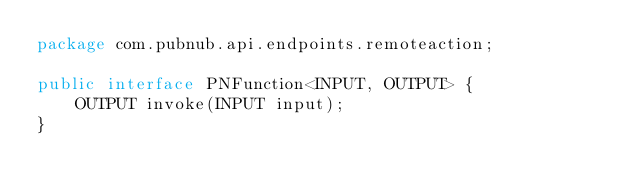<code> <loc_0><loc_0><loc_500><loc_500><_Java_>package com.pubnub.api.endpoints.remoteaction;

public interface PNFunction<INPUT, OUTPUT> {
    OUTPUT invoke(INPUT input);
}

</code> 